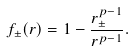<formula> <loc_0><loc_0><loc_500><loc_500>f _ { \pm } ( r ) = 1 - \frac { r _ { \pm } ^ { p - 1 } } { r ^ { p - 1 } } .</formula> 